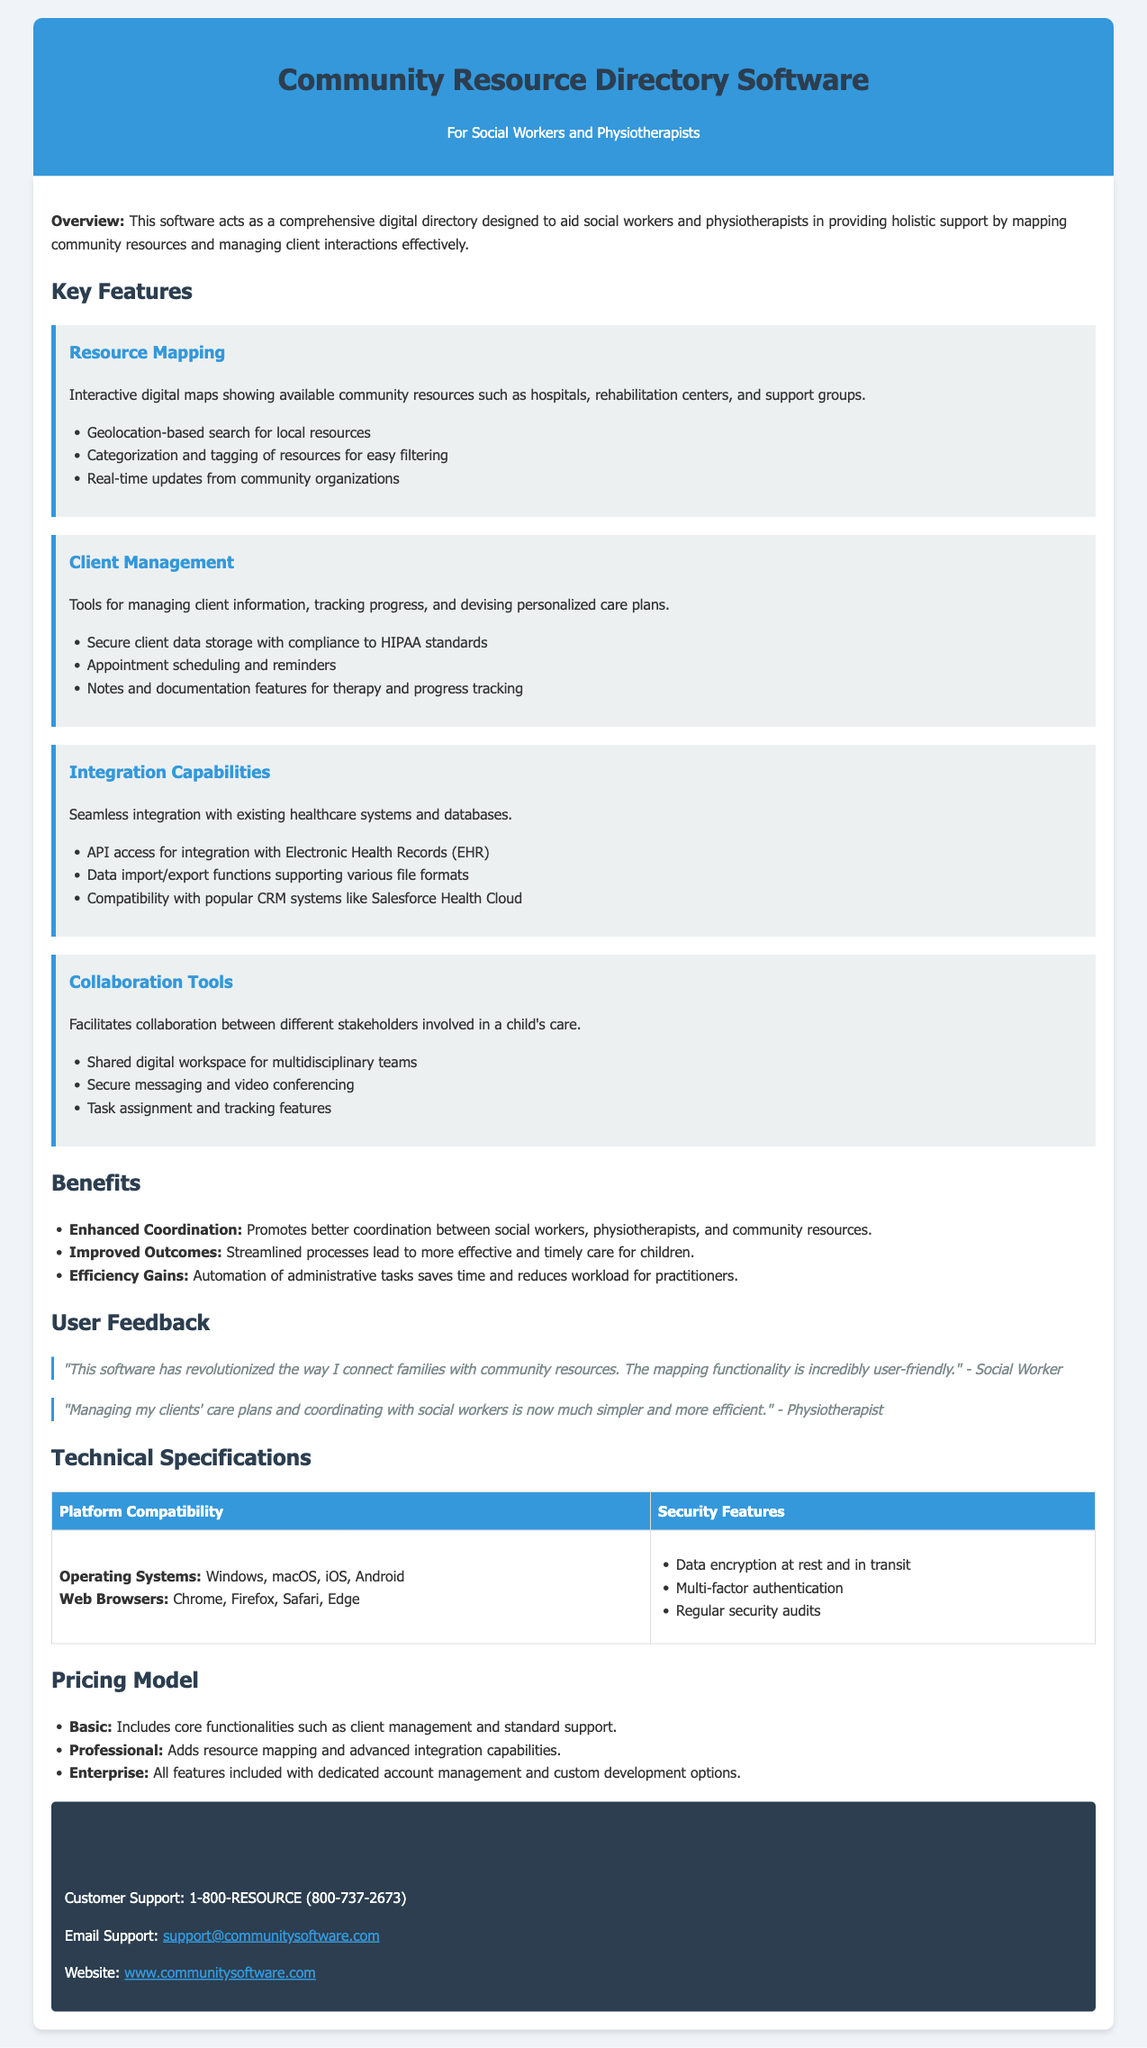what is the primary purpose of the software? The software aids social workers and physiotherapists in providing holistic support by mapping community resources and managing client interactions effectively.
Answer: holistic support what feature facilitates collaboration? This feature includes shared digital workspace for multidisciplinary teams, secure messaging, and task assignment.
Answer: Collaboration Tools how many pricing models are listed? The document outlines three distinct pricing models for the software.
Answer: three what is the contact number for customer support? The document provides a specific customer support contact number for inquiries and assistance.
Answer: 1-800-RESOURCE which operating systems is the software compatible with? The document mentions various operating systems the software can operate on.
Answer: Windows, macOS, iOS, Android what does the Resource Mapping feature provide? This feature includes interactive digital maps showing available community resources like hospitals and support groups.
Answer: interactive digital maps what security feature ensures data safety? The document lists multiple security features that protect sensitive information within the software.
Answer: Data encryption at rest and in transit what benefit does the software promote? The document specifies a clear advantage gained from using this software in care coordination.
Answer: Enhanced Coordination who provided feedback about the software? The feedback section includes quotes from two different professional roles regarding the usability of the software.
Answer: Social Worker and Physiotherapist 